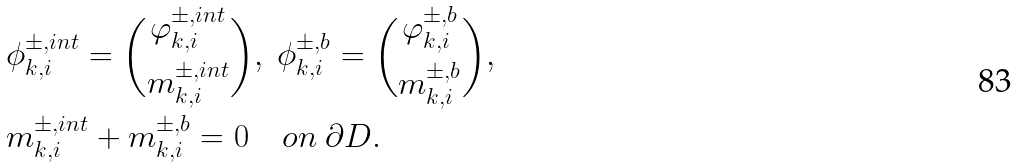Convert formula to latex. <formula><loc_0><loc_0><loc_500><loc_500>& \phi _ { k , i } ^ { \pm , i n t } = \binom { \varphi _ { k , i } ^ { \pm , i n t } } { m _ { k , i } ^ { \pm , i n t } } , \ \phi _ { k , i } ^ { \pm , b } = \binom { \varphi _ { k , i } ^ { \pm , b } } { m _ { k , i } ^ { \pm , b } } , \\ & m _ { k , i } ^ { \pm , i n t } + m _ { k , i } ^ { \pm , b } = 0 \quad o n \ \partial D .</formula> 